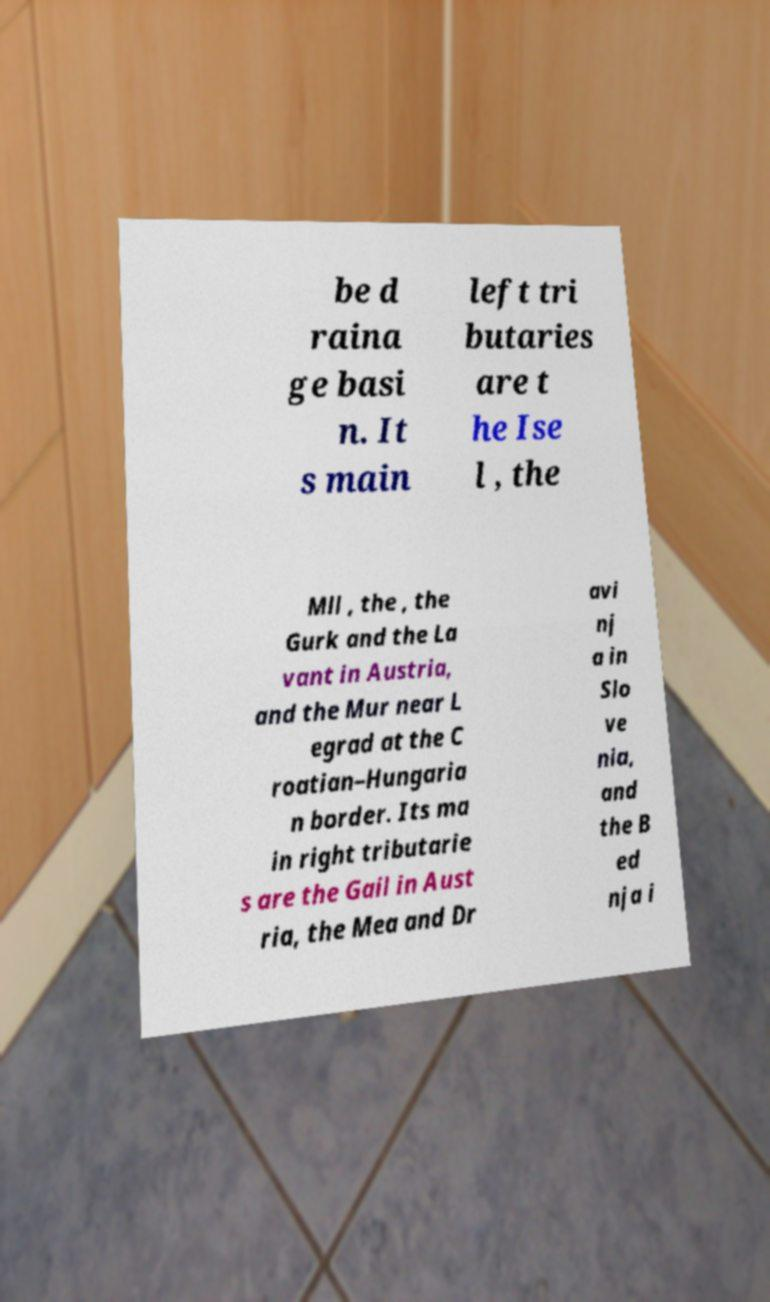There's text embedded in this image that I need extracted. Can you transcribe it verbatim? be d raina ge basi n. It s main left tri butaries are t he Ise l , the Mll , the , the Gurk and the La vant in Austria, and the Mur near L egrad at the C roatian–Hungaria n border. Its ma in right tributarie s are the Gail in Aust ria, the Mea and Dr avi nj a in Slo ve nia, and the B ed nja i 